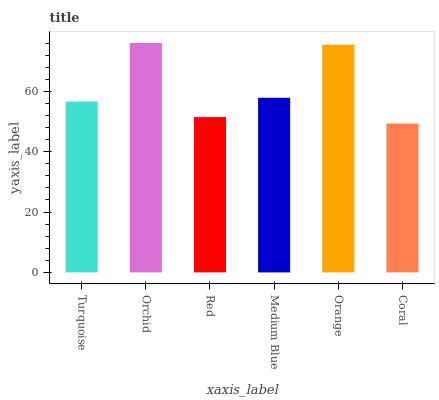Is Coral the minimum?
Answer yes or no. Yes. Is Orchid the maximum?
Answer yes or no. Yes. Is Red the minimum?
Answer yes or no. No. Is Red the maximum?
Answer yes or no. No. Is Orchid greater than Red?
Answer yes or no. Yes. Is Red less than Orchid?
Answer yes or no. Yes. Is Red greater than Orchid?
Answer yes or no. No. Is Orchid less than Red?
Answer yes or no. No. Is Medium Blue the high median?
Answer yes or no. Yes. Is Turquoise the low median?
Answer yes or no. Yes. Is Turquoise the high median?
Answer yes or no. No. Is Orange the low median?
Answer yes or no. No. 